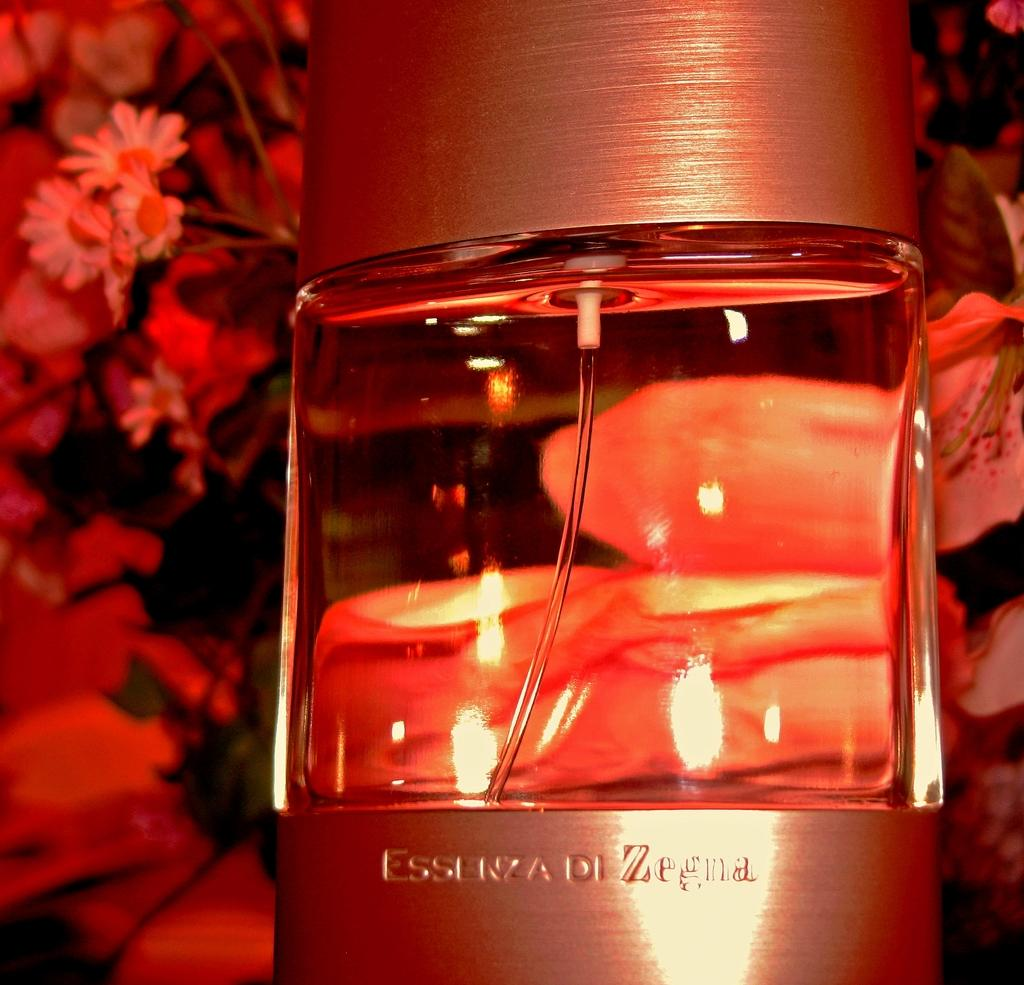Provide a one-sentence caption for the provided image. Perfume named Essenza Di Zegna in front of flower background. 